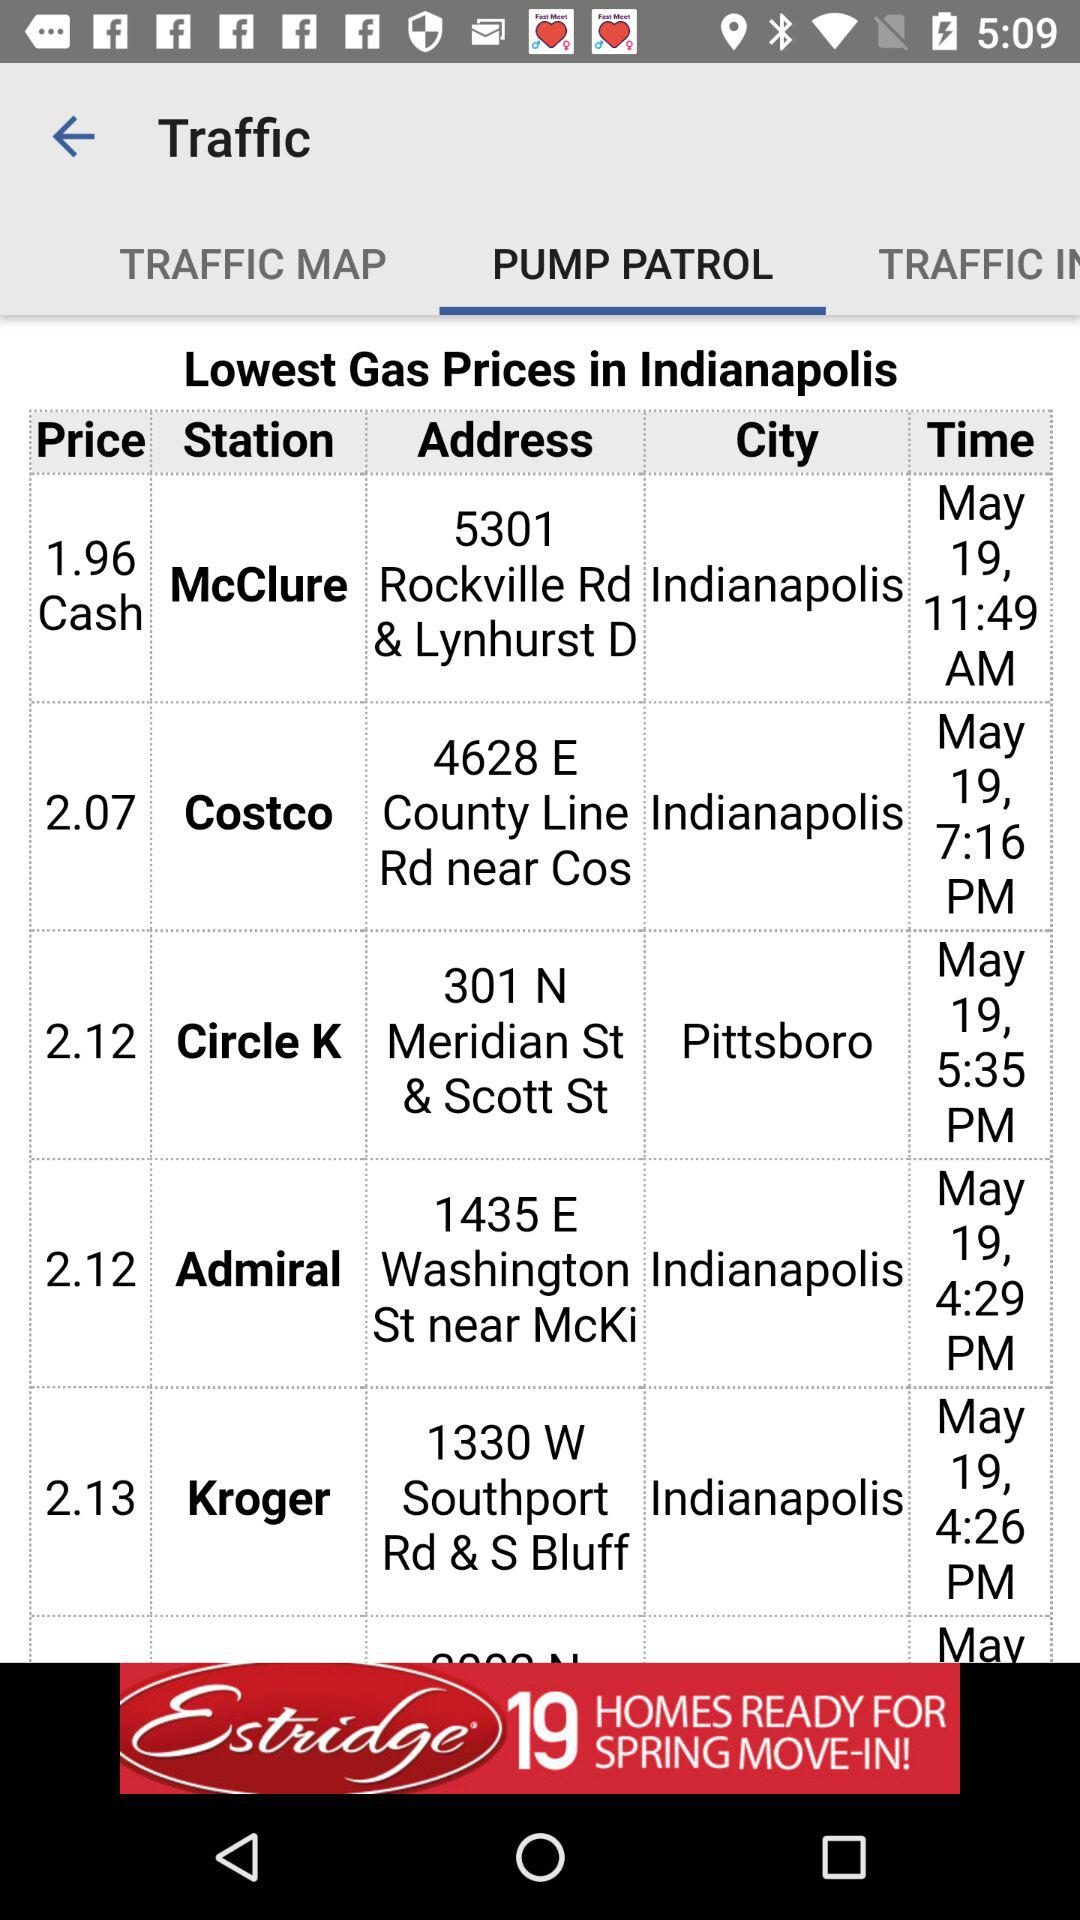What is the time for Kroger? The time for Kroger is May 19, 4:26 PM. 